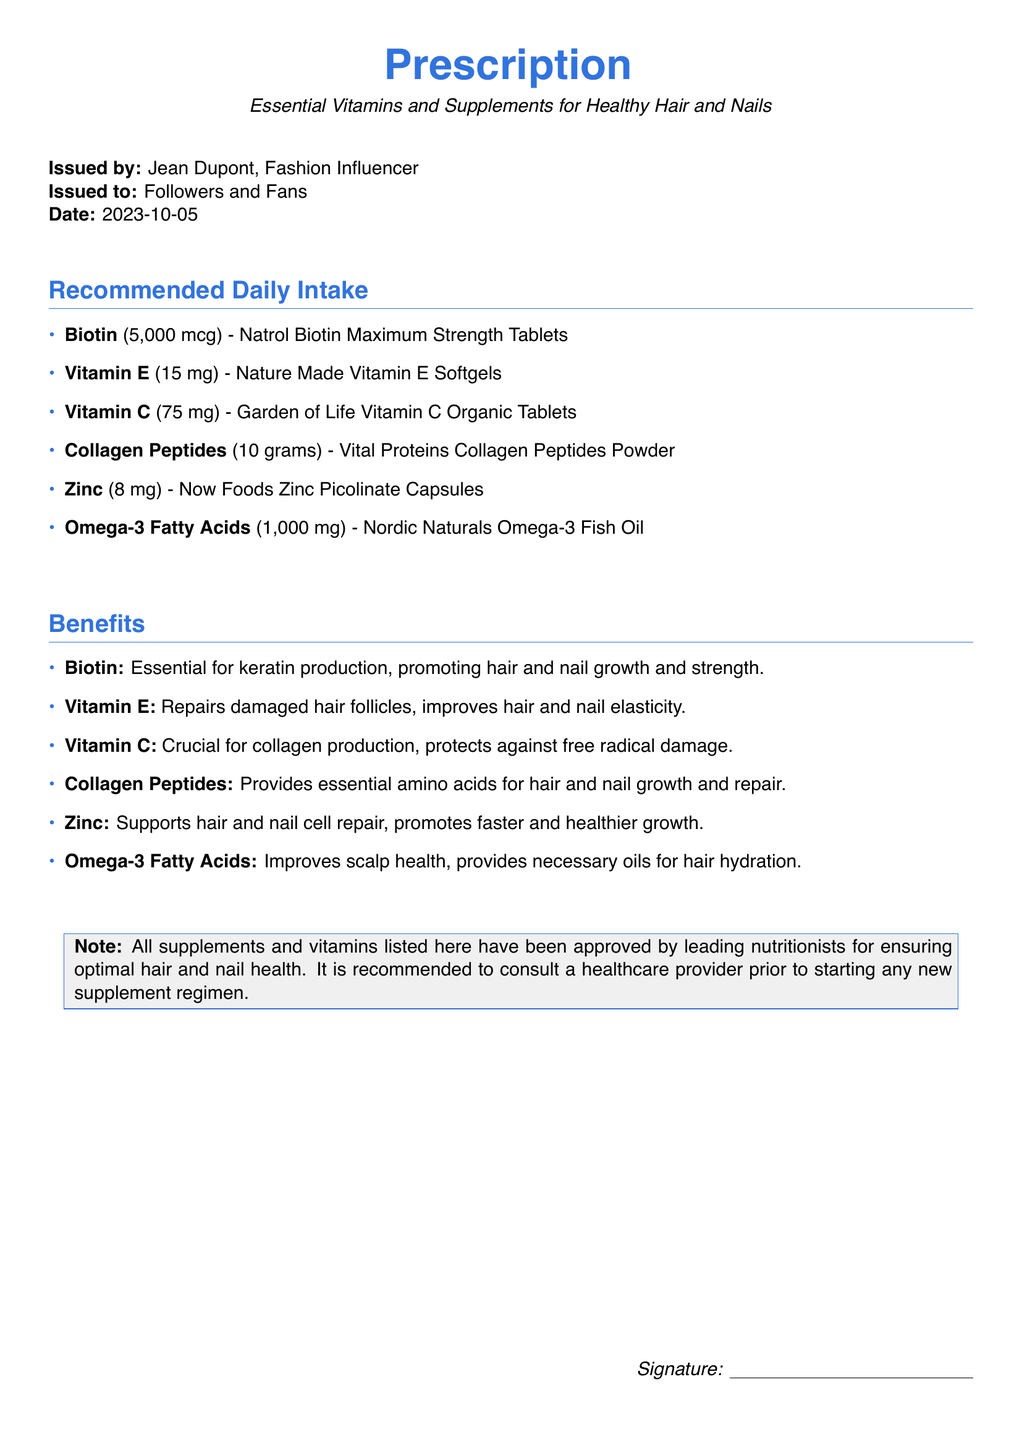What is the daily dosage of Biotin? The daily dosage of Biotin listed in the document is 5,000 mcg.
Answer: 5,000 mcg Who issued the Prescription? The Prescription was issued by Jean Dupont, who is identified as a fashion influencer.
Answer: Jean Dupont What is the brand of Vitamin E recommended? The document specifies Nature Made as the brand for Vitamin E.
Answer: Nature Made How many mg of Zinc should be taken daily? The document states a daily dosage of 8 mg for Zinc.
Answer: 8 mg What benefit does Vitamin C provide? Vitamin C is described as crucial for collagen production.
Answer: Collagen production What is the primary role of Omega-3 Fatty Acids according to the document? The document indicates that Omega-3 Fatty Acids improve scalp health.
Answer: Improve scalp health What is the date of issuance for this Prescription? The date of issuance is noted as 2023-10-05.
Answer: 2023-10-05 What type of document is this? This document is classified as a Prescription.
Answer: Prescription How many grams of Collagen Peptides are recommended daily? The document indicates a daily dosage of 10 grams for Collagen Peptides.
Answer: 10 grams 